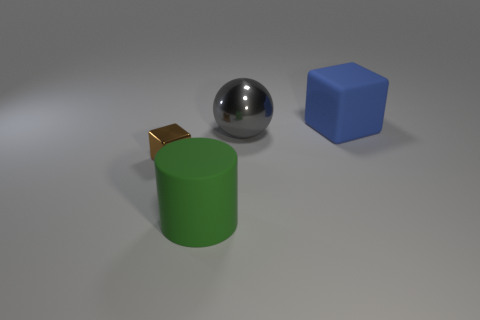Are there fewer small metal blocks to the right of the blue matte thing than tiny green matte spheres?
Keep it short and to the point. No. The big matte thing behind the large green cylinder is what color?
Your answer should be very brief. Blue. There is a big thing behind the metallic object behind the tiny brown shiny cube; what is its material?
Provide a succinct answer. Rubber. Is there a green matte object that has the same size as the shiny ball?
Give a very brief answer. Yes. How many objects are large objects in front of the blue cube or metal objects to the right of the tiny brown metallic thing?
Offer a terse response. 2. Is the size of the block behind the brown cube the same as the block that is in front of the gray thing?
Ensure brevity in your answer.  No. There is a green rubber object that is in front of the gray metallic object; are there any large rubber cylinders that are behind it?
Provide a succinct answer. No. There is a metallic block; what number of shiny cubes are in front of it?
Your response must be concise. 0. What number of other things are the same color as the big cylinder?
Offer a very short reply. 0. Is the number of balls to the left of the big green rubber thing less than the number of large blocks that are behind the small shiny object?
Your answer should be compact. Yes. 